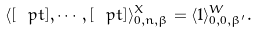Convert formula to latex. <formula><loc_0><loc_0><loc_500><loc_500>\langle [ \ p t ] , \cdots , [ \ p t ] \rangle ^ { X } _ { 0 , n , \beta } = \langle 1 \rangle ^ { W } _ { 0 , 0 , \beta ^ { \prime } } .</formula> 